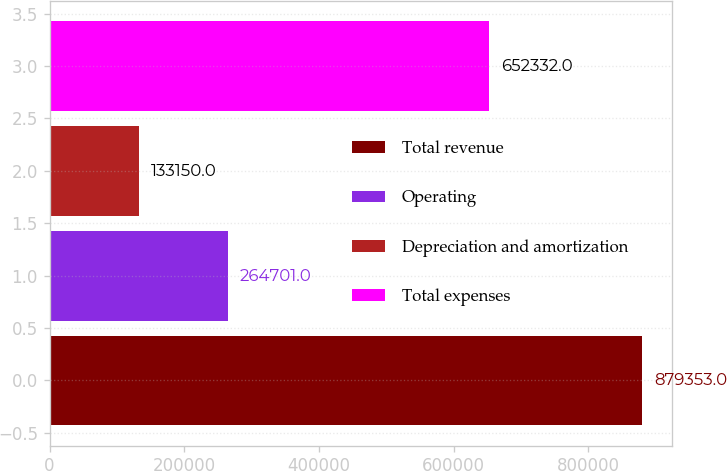Convert chart to OTSL. <chart><loc_0><loc_0><loc_500><loc_500><bar_chart><fcel>Total revenue<fcel>Operating<fcel>Depreciation and amortization<fcel>Total expenses<nl><fcel>879353<fcel>264701<fcel>133150<fcel>652332<nl></chart> 